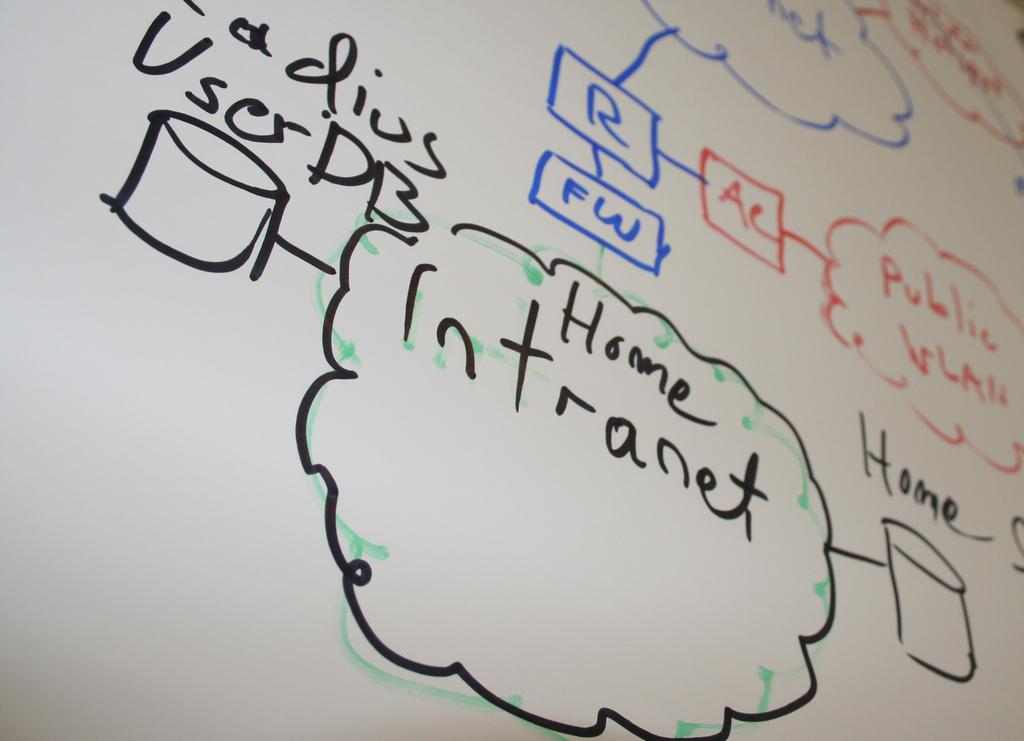What is the main subject of the image? The main subject of the image is a whiteboard. What can be seen on the whiteboard? There are letters and diagrams written on the whiteboard. What type of alarm is going off in the image? There is no alarm present in the image; it is a whiteboard with letters and diagrams. What type of punishment is being depicted in the image? There is no punishment being depicted in the image; it is a whiteboard with letters and diagrams. 